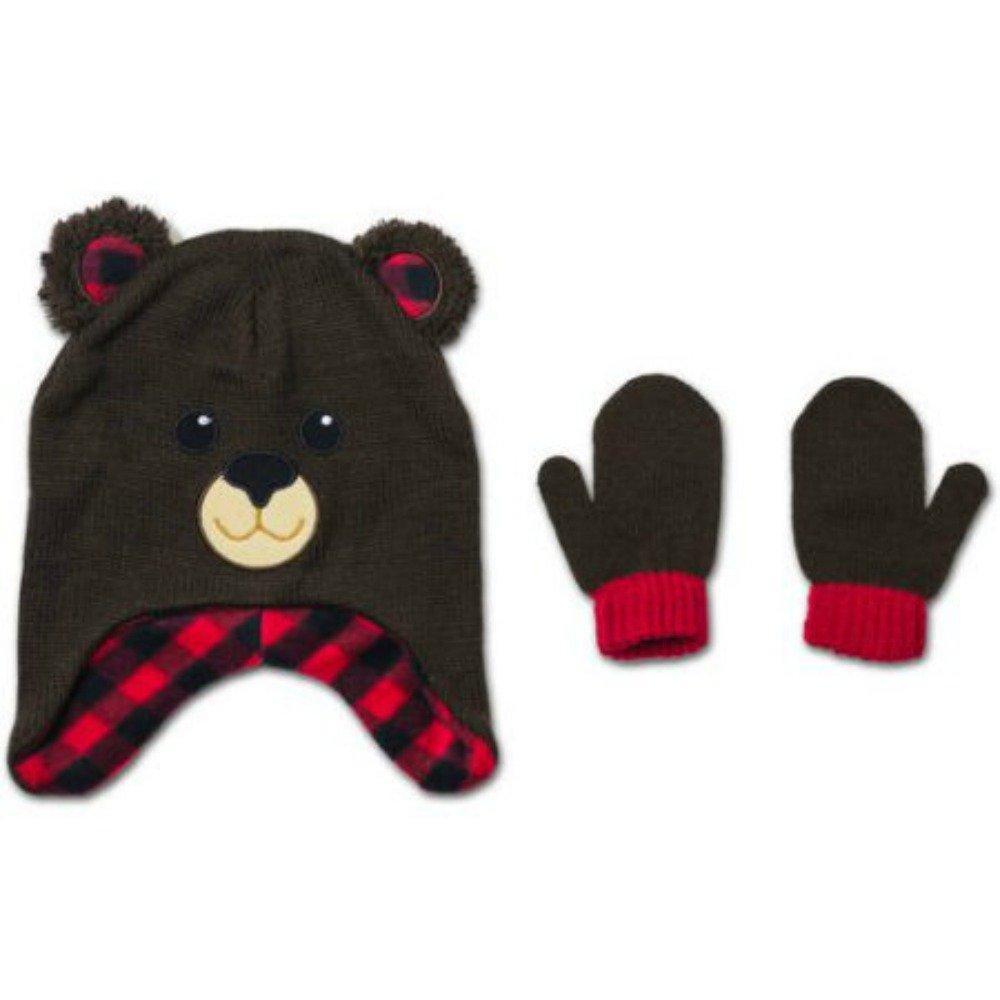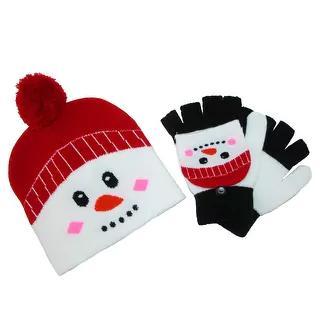The first image is the image on the left, the second image is the image on the right. For the images shown, is this caption "The left image includes mittens next to a cap with black ears and pink polka dotted bow, and the right image shows mittens by a cap with black ears and white dots on red." true? Answer yes or no. No. The first image is the image on the left, the second image is the image on the right. Considering the images on both sides, is "Both images in the pair show a winter hat and mittens which are Micky Mouse or Minnie Mouse themed." valid? Answer yes or no. No. 